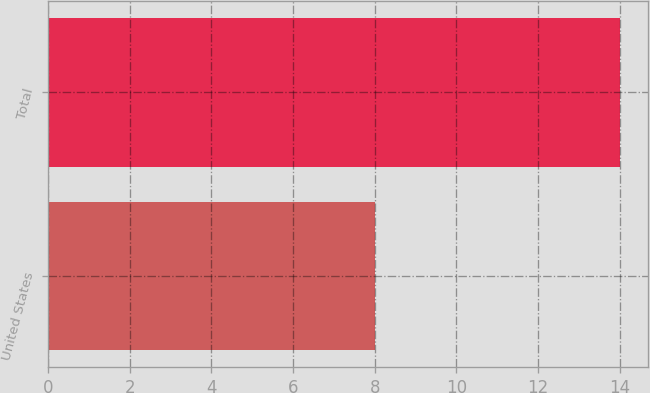Convert chart. <chart><loc_0><loc_0><loc_500><loc_500><bar_chart><fcel>United States<fcel>Total<nl><fcel>8<fcel>14<nl></chart> 